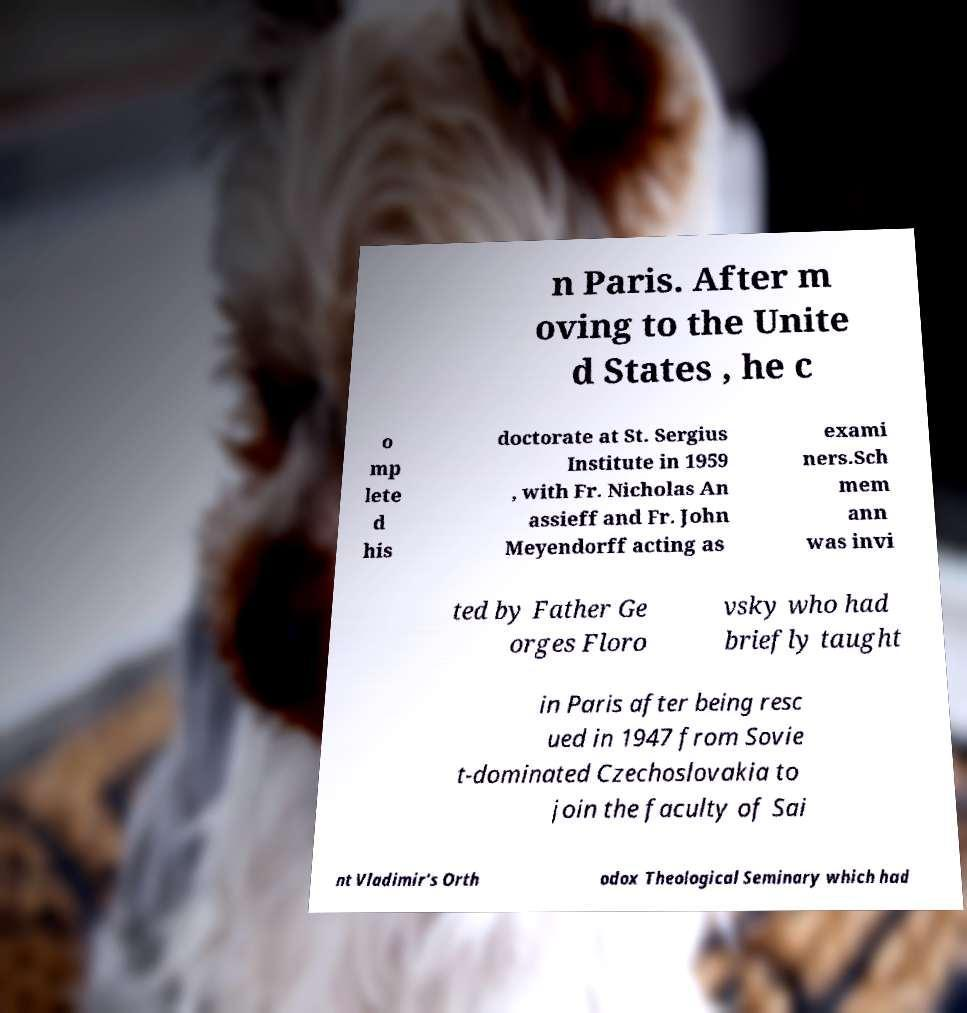Can you read and provide the text displayed in the image?This photo seems to have some interesting text. Can you extract and type it out for me? n Paris. After m oving to the Unite d States , he c o mp lete d his doctorate at St. Sergius Institute in 1959 , with Fr. Nicholas An assieff and Fr. John Meyendorff acting as exami ners.Sch mem ann was invi ted by Father Ge orges Floro vsky who had briefly taught in Paris after being resc ued in 1947 from Sovie t-dominated Czechoslovakia to join the faculty of Sai nt Vladimir's Orth odox Theological Seminary which had 